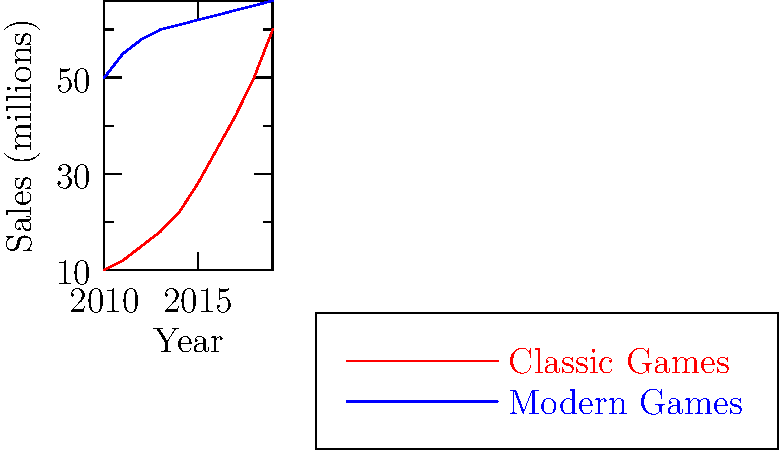Based on the line graph showing sales trends of classic and modern games from 2010 to 2019, in which year did the sales of classic games surpass those of modern games? To determine when classic game sales surpassed modern game sales, we need to follow these steps:

1. Observe the two lines: red for classic games and blue for modern games.
2. Look for the point where the red line crosses above the blue line.
3. Trace this intersection point to the x-axis to find the corresponding year.

Analyzing the graph:
- In 2010, modern games (blue line) had significantly higher sales.
- The classic games line (red) shows a steeper upward trend.
- The lines intersect between 2018 and 2019.
- After the intersection, the classic games line is above the modern games line.

Therefore, classic game sales surpassed modern game sales in 2019.
Answer: 2019 